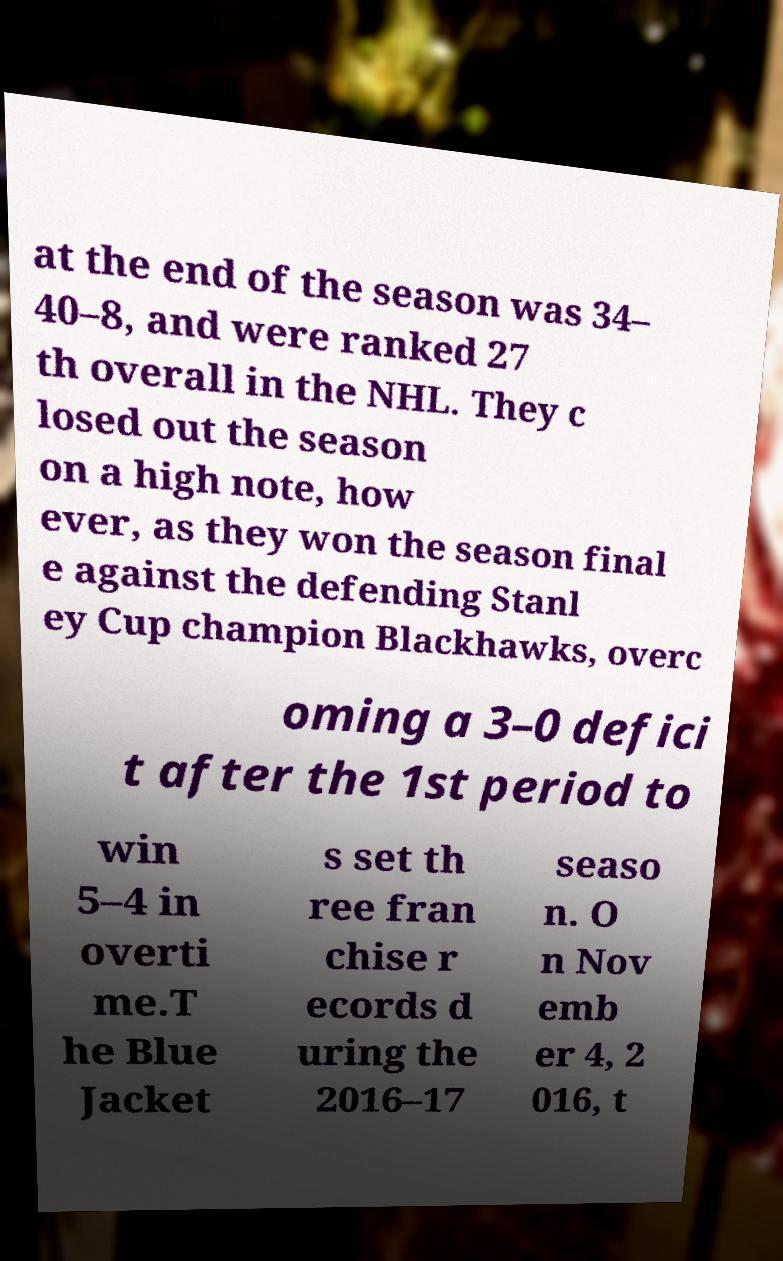Can you read and provide the text displayed in the image?This photo seems to have some interesting text. Can you extract and type it out for me? at the end of the season was 34– 40–8, and were ranked 27 th overall in the NHL. They c losed out the season on a high note, how ever, as they won the season final e against the defending Stanl ey Cup champion Blackhawks, overc oming a 3–0 defici t after the 1st period to win 5–4 in overti me.T he Blue Jacket s set th ree fran chise r ecords d uring the 2016–17 seaso n. O n Nov emb er 4, 2 016, t 